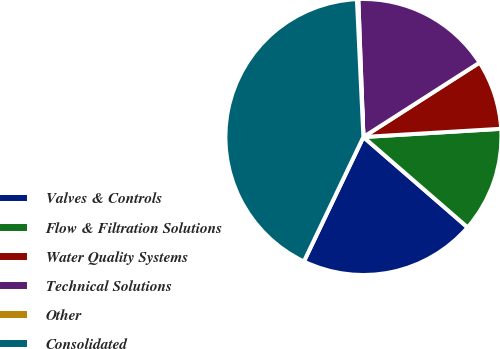Convert chart to OTSL. <chart><loc_0><loc_0><loc_500><loc_500><pie_chart><fcel>Valves & Controls<fcel>Flow & Filtration Solutions<fcel>Water Quality Systems<fcel>Technical Solutions<fcel>Other<fcel>Consolidated<nl><fcel>20.72%<fcel>12.32%<fcel>8.12%<fcel>16.52%<fcel>0.16%<fcel>42.15%<nl></chart> 